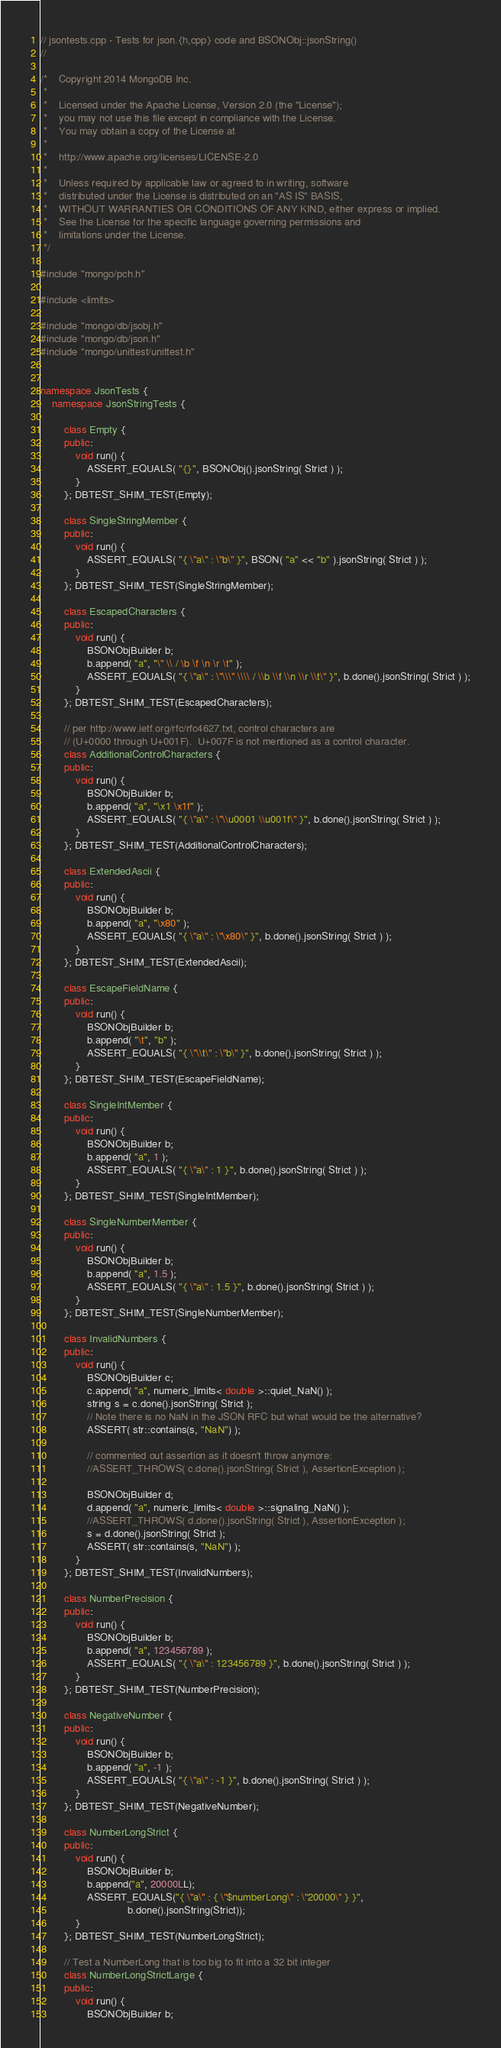<code> <loc_0><loc_0><loc_500><loc_500><_C++_>// jsontests.cpp - Tests for json.{h,cpp} code and BSONObj::jsonString()
//

/*    Copyright 2014 MongoDB Inc.
 *
 *    Licensed under the Apache License, Version 2.0 (the "License");
 *    you may not use this file except in compliance with the License.
 *    You may obtain a copy of the License at
 *
 *    http://www.apache.org/licenses/LICENSE-2.0
 *
 *    Unless required by applicable law or agreed to in writing, software
 *    distributed under the License is distributed on an "AS IS" BASIS,
 *    WITHOUT WARRANTIES OR CONDITIONS OF ANY KIND, either express or implied.
 *    See the License for the specific language governing permissions and
 *    limitations under the License.
 */

#include "mongo/pch.h"

#include <limits>

#include "mongo/db/jsobj.h"
#include "mongo/db/json.h"
#include "mongo/unittest/unittest.h"


namespace JsonTests {
    namespace JsonStringTests {

        class Empty {
        public:
            void run() {
                ASSERT_EQUALS( "{}", BSONObj().jsonString( Strict ) );
            }
        }; DBTEST_SHIM_TEST(Empty);

        class SingleStringMember {
        public:
            void run() {
                ASSERT_EQUALS( "{ \"a\" : \"b\" }", BSON( "a" << "b" ).jsonString( Strict ) );
            }
        }; DBTEST_SHIM_TEST(SingleStringMember);

        class EscapedCharacters {
        public:
            void run() {
                BSONObjBuilder b;
                b.append( "a", "\" \\ / \b \f \n \r \t" );
                ASSERT_EQUALS( "{ \"a\" : \"\\\" \\\\ / \\b \\f \\n \\r \\t\" }", b.done().jsonString( Strict ) );
            }
        }; DBTEST_SHIM_TEST(EscapedCharacters);

        // per http://www.ietf.org/rfc/rfc4627.txt, control characters are
        // (U+0000 through U+001F).  U+007F is not mentioned as a control character.
        class AdditionalControlCharacters {
        public:
            void run() {
                BSONObjBuilder b;
                b.append( "a", "\x1 \x1f" );
                ASSERT_EQUALS( "{ \"a\" : \"\\u0001 \\u001f\" }", b.done().jsonString( Strict ) );
            }
        }; DBTEST_SHIM_TEST(AdditionalControlCharacters);

        class ExtendedAscii {
        public:
            void run() {
                BSONObjBuilder b;
                b.append( "a", "\x80" );
                ASSERT_EQUALS( "{ \"a\" : \"\x80\" }", b.done().jsonString( Strict ) );
            }
        }; DBTEST_SHIM_TEST(ExtendedAscii);

        class EscapeFieldName {
        public:
            void run() {
                BSONObjBuilder b;
                b.append( "\t", "b" );
                ASSERT_EQUALS( "{ \"\\t\" : \"b\" }", b.done().jsonString( Strict ) );
            }
        }; DBTEST_SHIM_TEST(EscapeFieldName);

        class SingleIntMember {
        public:
            void run() {
                BSONObjBuilder b;
                b.append( "a", 1 );
                ASSERT_EQUALS( "{ \"a\" : 1 }", b.done().jsonString( Strict ) );
            }
        }; DBTEST_SHIM_TEST(SingleIntMember);

        class SingleNumberMember {
        public:
            void run() {
                BSONObjBuilder b;
                b.append( "a", 1.5 );
                ASSERT_EQUALS( "{ \"a\" : 1.5 }", b.done().jsonString( Strict ) );
            }
        }; DBTEST_SHIM_TEST(SingleNumberMember);

        class InvalidNumbers {
        public:
            void run() {
                BSONObjBuilder c;
                c.append( "a", numeric_limits< double >::quiet_NaN() );
                string s = c.done().jsonString( Strict );
                // Note there is no NaN in the JSON RFC but what would be the alternative?
                ASSERT( str::contains(s, "NaN") );

                // commented out assertion as it doesn't throw anymore:
                //ASSERT_THROWS( c.done().jsonString( Strict ), AssertionException );

                BSONObjBuilder d;
                d.append( "a", numeric_limits< double >::signaling_NaN() );
                //ASSERT_THROWS( d.done().jsonString( Strict ), AssertionException );
                s = d.done().jsonString( Strict );
                ASSERT( str::contains(s, "NaN") );
            }
        }; DBTEST_SHIM_TEST(InvalidNumbers);

        class NumberPrecision {
        public:
            void run() {
                BSONObjBuilder b;
                b.append( "a", 123456789 );
                ASSERT_EQUALS( "{ \"a\" : 123456789 }", b.done().jsonString( Strict ) );
            }
        }; DBTEST_SHIM_TEST(NumberPrecision);

        class NegativeNumber {
        public:
            void run() {
                BSONObjBuilder b;
                b.append( "a", -1 );
                ASSERT_EQUALS( "{ \"a\" : -1 }", b.done().jsonString( Strict ) );
            }
        }; DBTEST_SHIM_TEST(NegativeNumber);

        class NumberLongStrict {
        public:
            void run() {
                BSONObjBuilder b;
                b.append("a", 20000LL);
                ASSERT_EQUALS("{ \"a\" : { \"$numberLong\" : \"20000\" } }",
                              b.done().jsonString(Strict));
            }
        }; DBTEST_SHIM_TEST(NumberLongStrict);

        // Test a NumberLong that is too big to fit into a 32 bit integer
        class NumberLongStrictLarge {
        public:
            void run() {
                BSONObjBuilder b;</code> 